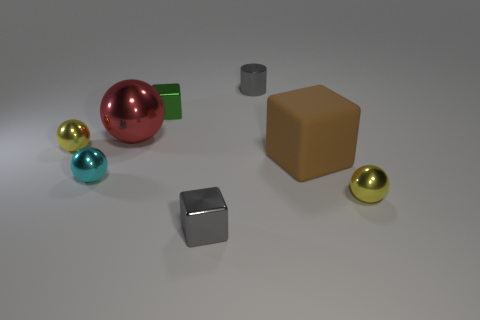Subtract all brown cylinders. Subtract all cyan blocks. How many cylinders are left? 1 Add 1 tiny shiny balls. How many objects exist? 9 Subtract all cubes. How many objects are left? 5 Add 7 large metallic spheres. How many large metallic spheres are left? 8 Add 7 big gray rubber spheres. How many big gray rubber spheres exist? 7 Subtract 0 green cylinders. How many objects are left? 8 Subtract all tiny green things. Subtract all tiny cyan balls. How many objects are left? 6 